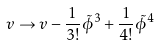Convert formula to latex. <formula><loc_0><loc_0><loc_500><loc_500>v \to v - \frac { 1 } { 3 ! } \tilde { \phi } ^ { 3 } + \frac { 1 } { 4 ! } \tilde { \phi } ^ { 4 }</formula> 